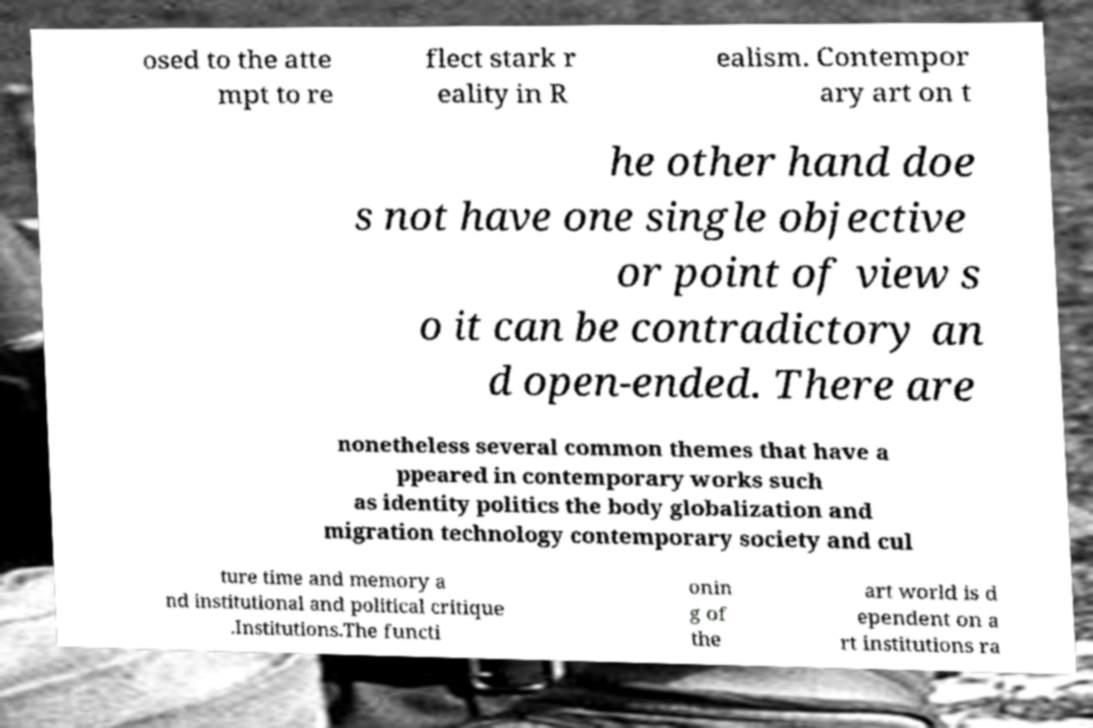Could you assist in decoding the text presented in this image and type it out clearly? osed to the atte mpt to re flect stark r eality in R ealism. Contempor ary art on t he other hand doe s not have one single objective or point of view s o it can be contradictory an d open-ended. There are nonetheless several common themes that have a ppeared in contemporary works such as identity politics the body globalization and migration technology contemporary society and cul ture time and memory a nd institutional and political critique .Institutions.The functi onin g of the art world is d ependent on a rt institutions ra 